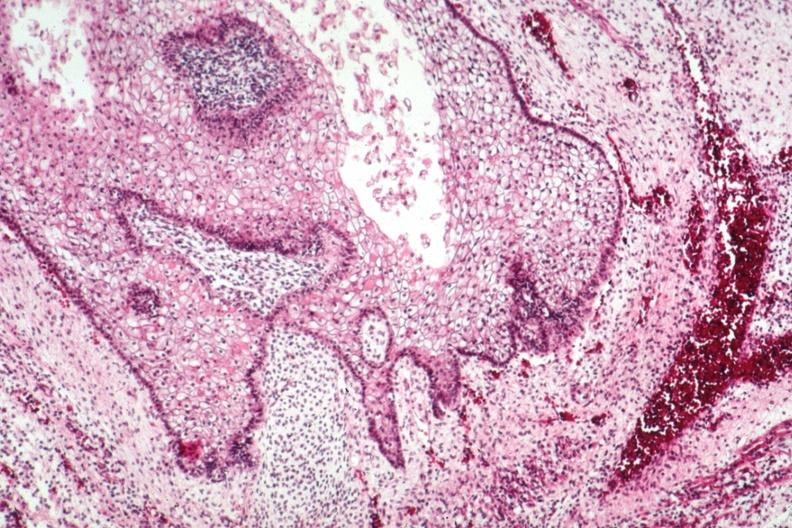what does this image show?
Answer the question using a single word or phrase. Squamous epithelial component 